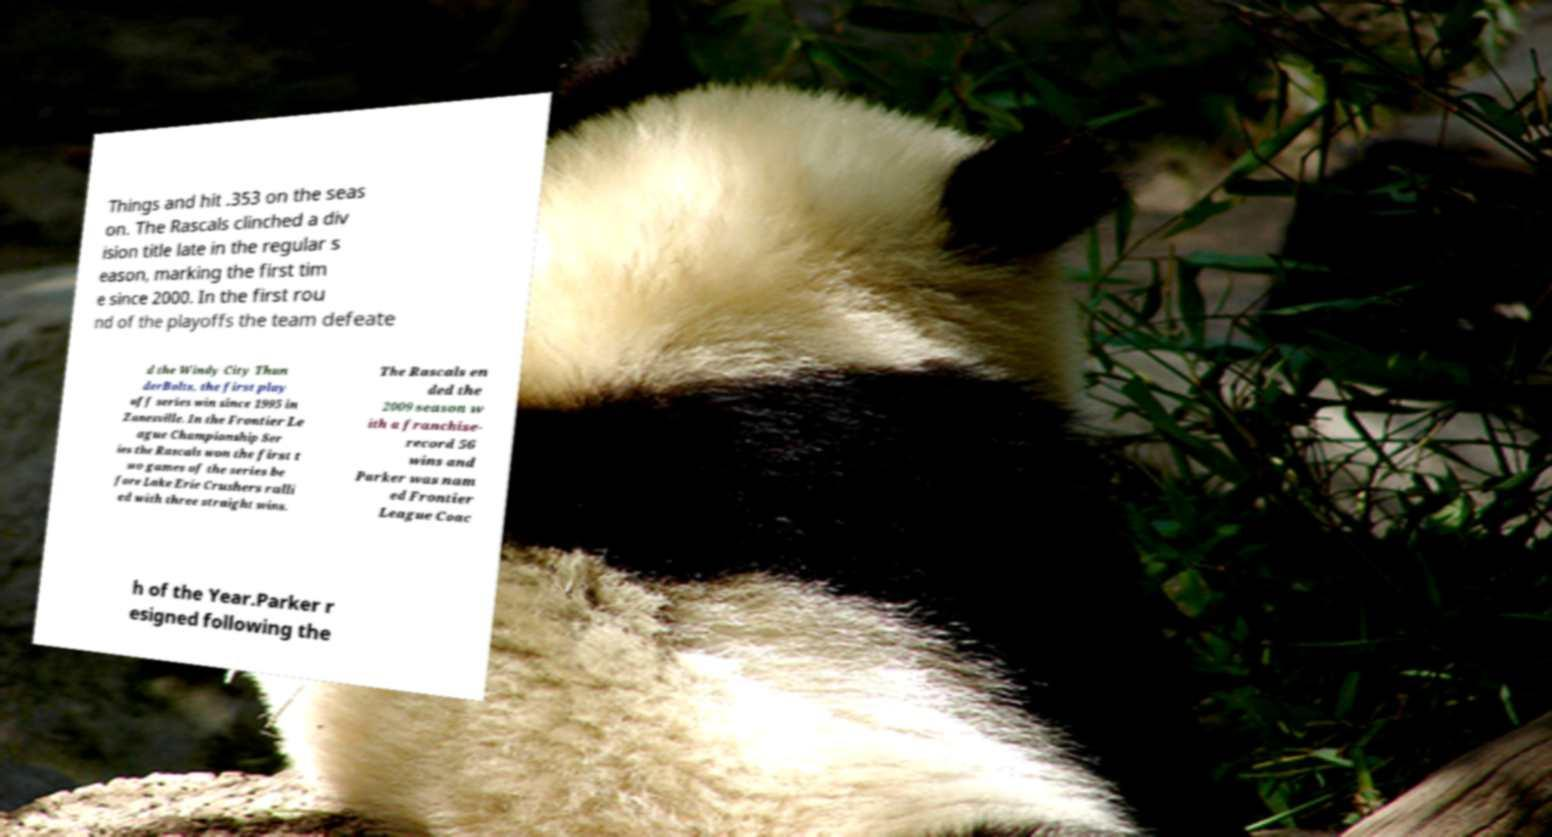Can you accurately transcribe the text from the provided image for me? Things and hit .353 on the seas on. The Rascals clinched a div ision title late in the regular s eason, marking the first tim e since 2000. In the first rou nd of the playoffs the team defeate d the Windy City Thun derBolts, the first play off series win since 1995 in Zanesville. In the Frontier Le ague Championship Ser ies the Rascals won the first t wo games of the series be fore Lake Erie Crushers ralli ed with three straight wins. The Rascals en ded the 2009 season w ith a franchise- record 56 wins and Parker was nam ed Frontier League Coac h of the Year.Parker r esigned following the 